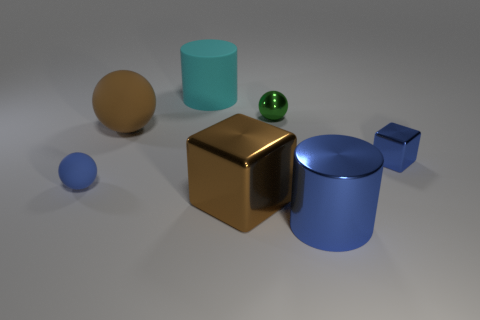Subtract all small rubber balls. How many balls are left? 2 Add 2 large yellow objects. How many objects exist? 9 Subtract all blocks. How many objects are left? 5 Subtract 0 red spheres. How many objects are left? 7 Subtract all gray spheres. Subtract all brown cylinders. How many spheres are left? 3 Subtract all big metal cylinders. Subtract all big blue things. How many objects are left? 5 Add 1 brown metallic cubes. How many brown metallic cubes are left? 2 Add 5 tiny blue matte balls. How many tiny blue matte balls exist? 6 